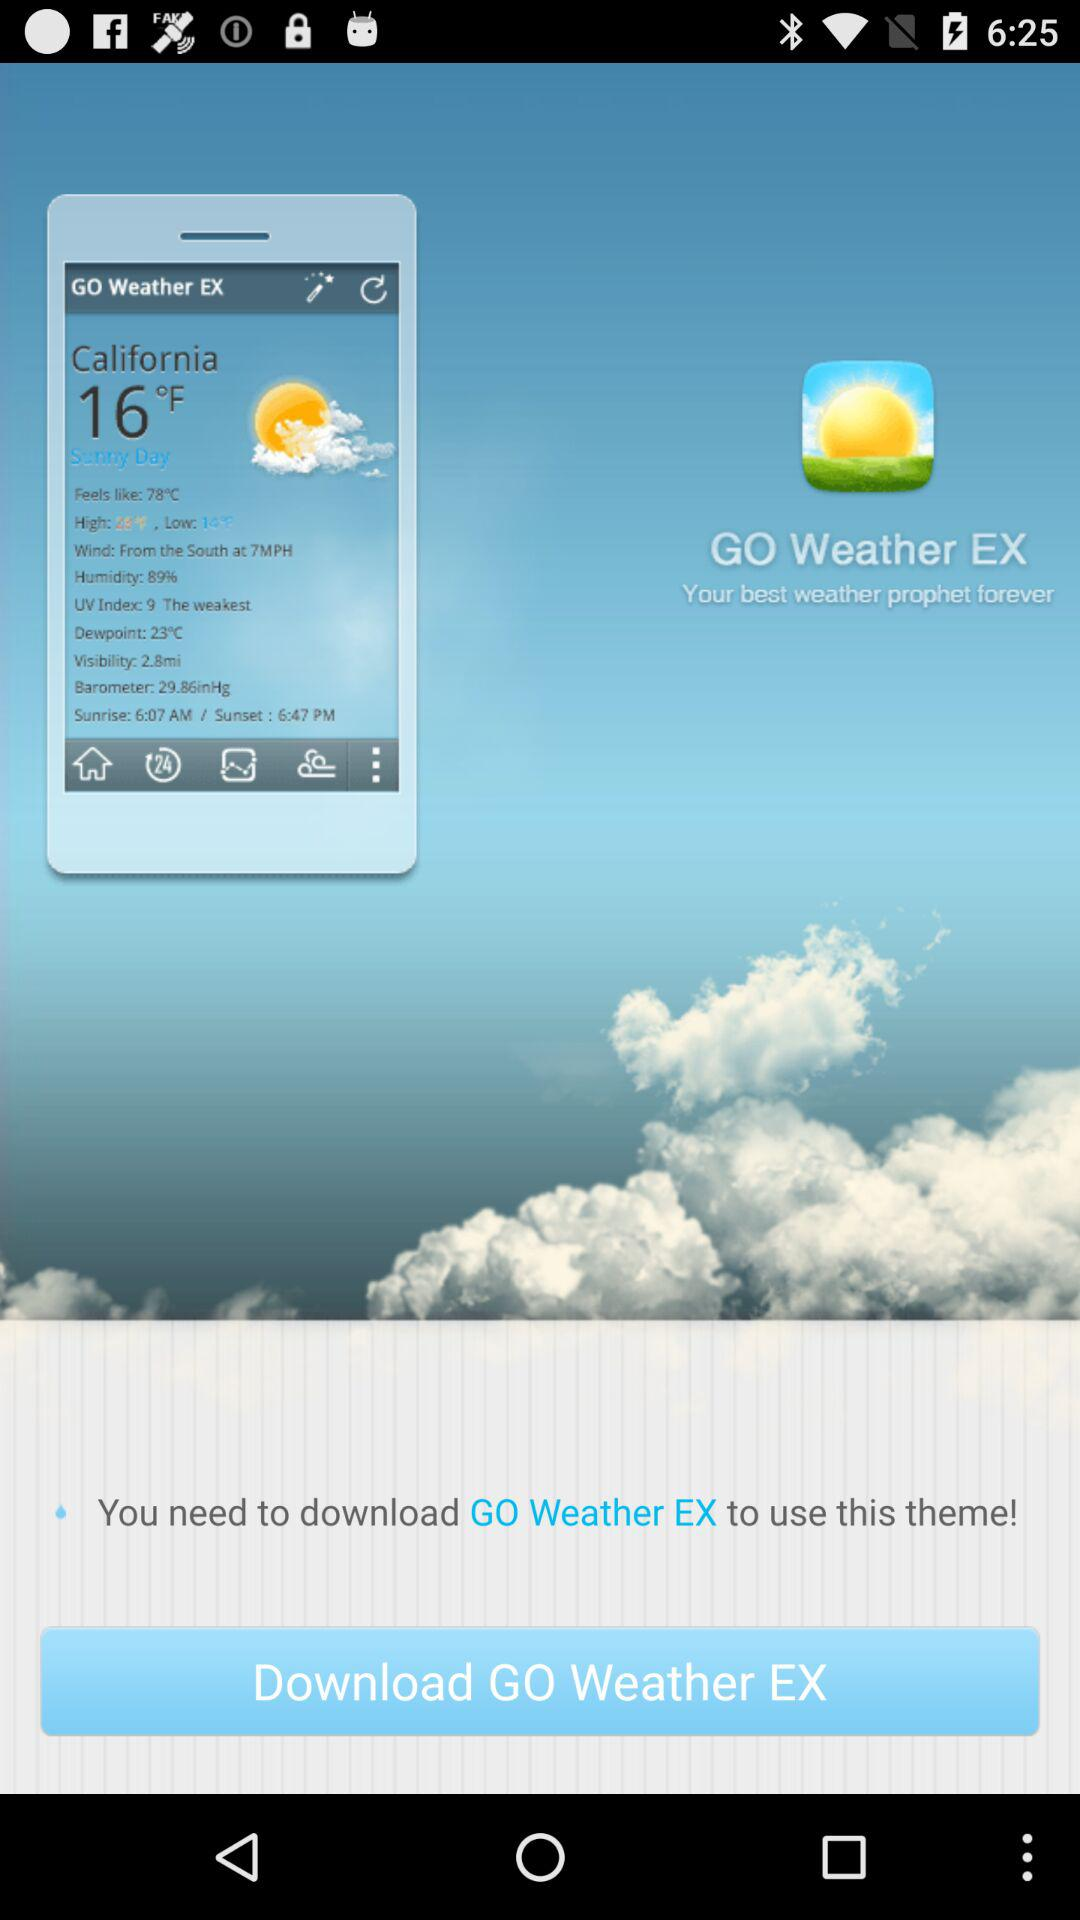What is the temperature in California? The temperature is 16°F. 